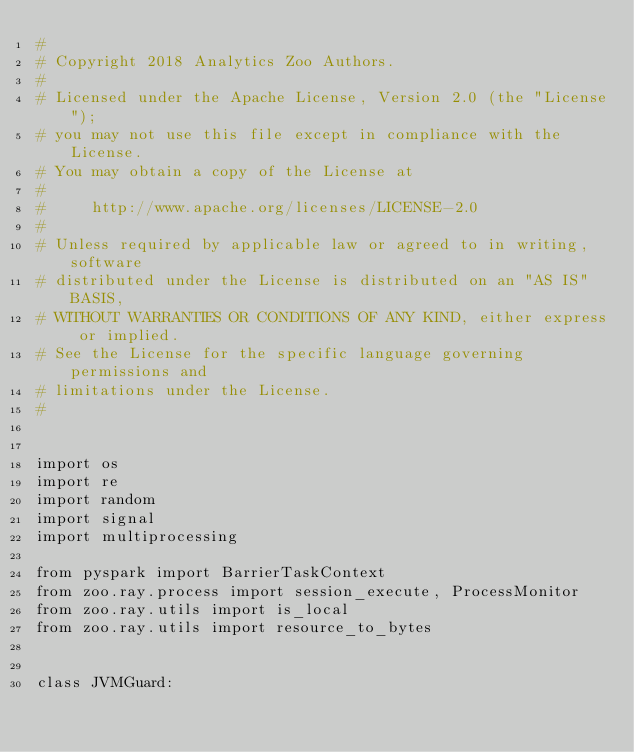Convert code to text. <code><loc_0><loc_0><loc_500><loc_500><_Python_>#
# Copyright 2018 Analytics Zoo Authors.
#
# Licensed under the Apache License, Version 2.0 (the "License");
# you may not use this file except in compliance with the License.
# You may obtain a copy of the License at
#
#     http://www.apache.org/licenses/LICENSE-2.0
#
# Unless required by applicable law or agreed to in writing, software
# distributed under the License is distributed on an "AS IS" BASIS,
# WITHOUT WARRANTIES OR CONDITIONS OF ANY KIND, either express or implied.
# See the License for the specific language governing permissions and
# limitations under the License.
#


import os
import re
import random
import signal
import multiprocessing

from pyspark import BarrierTaskContext
from zoo.ray.process import session_execute, ProcessMonitor
from zoo.ray.utils import is_local
from zoo.ray.utils import resource_to_bytes


class JVMGuard:</code> 